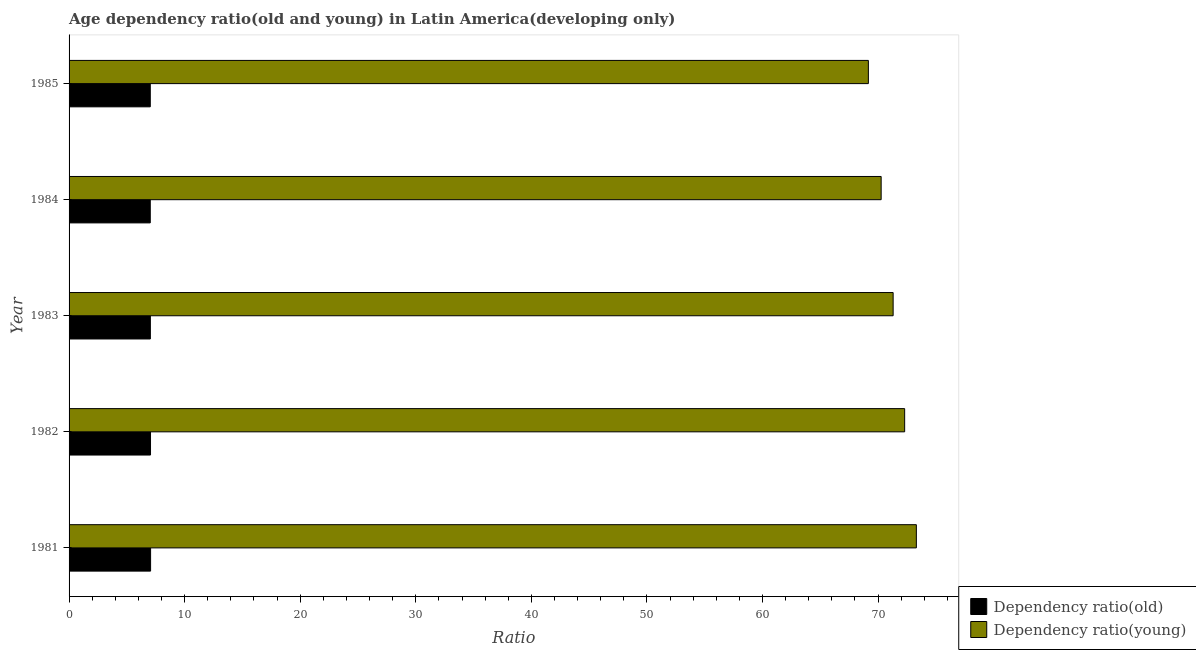How many groups of bars are there?
Offer a very short reply. 5. Are the number of bars on each tick of the Y-axis equal?
Keep it short and to the point. Yes. How many bars are there on the 4th tick from the bottom?
Ensure brevity in your answer.  2. What is the label of the 3rd group of bars from the top?
Offer a very short reply. 1983. What is the age dependency ratio(young) in 1985?
Keep it short and to the point. 69.16. Across all years, what is the maximum age dependency ratio(old)?
Your answer should be compact. 7.05. Across all years, what is the minimum age dependency ratio(young)?
Provide a succinct answer. 69.16. In which year was the age dependency ratio(young) maximum?
Your response must be concise. 1981. What is the total age dependency ratio(old) in the graph?
Ensure brevity in your answer.  35.19. What is the difference between the age dependency ratio(young) in 1981 and that in 1983?
Provide a succinct answer. 2.01. What is the difference between the age dependency ratio(young) in 1983 and the age dependency ratio(old) in 1982?
Your response must be concise. 64.26. What is the average age dependency ratio(young) per year?
Provide a short and direct response. 71.27. In the year 1981, what is the difference between the age dependency ratio(old) and age dependency ratio(young)?
Make the answer very short. -66.26. What is the ratio of the age dependency ratio(old) in 1982 to that in 1983?
Make the answer very short. 1. What is the difference between the highest and the second highest age dependency ratio(old)?
Offer a terse response. 0.01. What is the difference between the highest and the lowest age dependency ratio(old)?
Offer a very short reply. 0.03. What does the 2nd bar from the top in 1981 represents?
Provide a short and direct response. Dependency ratio(old). What does the 1st bar from the bottom in 1985 represents?
Make the answer very short. Dependency ratio(old). Does the graph contain any zero values?
Your answer should be very brief. No. How many legend labels are there?
Give a very brief answer. 2. What is the title of the graph?
Make the answer very short. Age dependency ratio(old and young) in Latin America(developing only). What is the label or title of the X-axis?
Give a very brief answer. Ratio. What is the Ratio of Dependency ratio(old) in 1981?
Offer a terse response. 7.05. What is the Ratio of Dependency ratio(young) in 1981?
Ensure brevity in your answer.  73.31. What is the Ratio of Dependency ratio(old) in 1982?
Give a very brief answer. 7.05. What is the Ratio of Dependency ratio(young) in 1982?
Your response must be concise. 72.3. What is the Ratio of Dependency ratio(old) in 1983?
Your response must be concise. 7.03. What is the Ratio in Dependency ratio(young) in 1983?
Your answer should be very brief. 71.3. What is the Ratio in Dependency ratio(old) in 1984?
Your response must be concise. 7.03. What is the Ratio in Dependency ratio(young) in 1984?
Your answer should be compact. 70.27. What is the Ratio in Dependency ratio(old) in 1985?
Provide a succinct answer. 7.03. What is the Ratio of Dependency ratio(young) in 1985?
Give a very brief answer. 69.16. Across all years, what is the maximum Ratio in Dependency ratio(old)?
Offer a very short reply. 7.05. Across all years, what is the maximum Ratio of Dependency ratio(young)?
Your answer should be compact. 73.31. Across all years, what is the minimum Ratio of Dependency ratio(old)?
Ensure brevity in your answer.  7.03. Across all years, what is the minimum Ratio in Dependency ratio(young)?
Your response must be concise. 69.16. What is the total Ratio of Dependency ratio(old) in the graph?
Offer a very short reply. 35.19. What is the total Ratio in Dependency ratio(young) in the graph?
Ensure brevity in your answer.  356.35. What is the difference between the Ratio in Dependency ratio(old) in 1981 and that in 1982?
Provide a short and direct response. 0.01. What is the difference between the Ratio in Dependency ratio(young) in 1981 and that in 1982?
Your answer should be compact. 1.01. What is the difference between the Ratio of Dependency ratio(old) in 1981 and that in 1983?
Offer a terse response. 0.02. What is the difference between the Ratio of Dependency ratio(young) in 1981 and that in 1983?
Ensure brevity in your answer.  2.01. What is the difference between the Ratio of Dependency ratio(old) in 1981 and that in 1984?
Your answer should be very brief. 0.03. What is the difference between the Ratio in Dependency ratio(young) in 1981 and that in 1984?
Provide a succinct answer. 3.05. What is the difference between the Ratio in Dependency ratio(old) in 1981 and that in 1985?
Your answer should be compact. 0.03. What is the difference between the Ratio of Dependency ratio(young) in 1981 and that in 1985?
Ensure brevity in your answer.  4.15. What is the difference between the Ratio in Dependency ratio(old) in 1982 and that in 1983?
Provide a succinct answer. 0.01. What is the difference between the Ratio of Dependency ratio(young) in 1982 and that in 1983?
Keep it short and to the point. 1. What is the difference between the Ratio in Dependency ratio(old) in 1982 and that in 1984?
Offer a very short reply. 0.02. What is the difference between the Ratio of Dependency ratio(young) in 1982 and that in 1984?
Provide a succinct answer. 2.03. What is the difference between the Ratio of Dependency ratio(old) in 1982 and that in 1985?
Your response must be concise. 0.02. What is the difference between the Ratio in Dependency ratio(young) in 1982 and that in 1985?
Offer a terse response. 3.14. What is the difference between the Ratio in Dependency ratio(old) in 1983 and that in 1984?
Offer a terse response. 0.01. What is the difference between the Ratio in Dependency ratio(young) in 1983 and that in 1984?
Give a very brief answer. 1.04. What is the difference between the Ratio of Dependency ratio(old) in 1983 and that in 1985?
Offer a very short reply. 0.01. What is the difference between the Ratio of Dependency ratio(young) in 1983 and that in 1985?
Make the answer very short. 2.14. What is the difference between the Ratio in Dependency ratio(old) in 1984 and that in 1985?
Give a very brief answer. -0. What is the difference between the Ratio in Dependency ratio(young) in 1984 and that in 1985?
Offer a very short reply. 1.11. What is the difference between the Ratio in Dependency ratio(old) in 1981 and the Ratio in Dependency ratio(young) in 1982?
Make the answer very short. -65.25. What is the difference between the Ratio of Dependency ratio(old) in 1981 and the Ratio of Dependency ratio(young) in 1983?
Keep it short and to the point. -64.25. What is the difference between the Ratio in Dependency ratio(old) in 1981 and the Ratio in Dependency ratio(young) in 1984?
Offer a terse response. -63.21. What is the difference between the Ratio in Dependency ratio(old) in 1981 and the Ratio in Dependency ratio(young) in 1985?
Provide a succinct answer. -62.11. What is the difference between the Ratio of Dependency ratio(old) in 1982 and the Ratio of Dependency ratio(young) in 1983?
Provide a short and direct response. -64.26. What is the difference between the Ratio of Dependency ratio(old) in 1982 and the Ratio of Dependency ratio(young) in 1984?
Give a very brief answer. -63.22. What is the difference between the Ratio in Dependency ratio(old) in 1982 and the Ratio in Dependency ratio(young) in 1985?
Offer a very short reply. -62.11. What is the difference between the Ratio in Dependency ratio(old) in 1983 and the Ratio in Dependency ratio(young) in 1984?
Your response must be concise. -63.23. What is the difference between the Ratio in Dependency ratio(old) in 1983 and the Ratio in Dependency ratio(young) in 1985?
Offer a terse response. -62.13. What is the difference between the Ratio of Dependency ratio(old) in 1984 and the Ratio of Dependency ratio(young) in 1985?
Offer a very short reply. -62.14. What is the average Ratio in Dependency ratio(old) per year?
Your response must be concise. 7.04. What is the average Ratio in Dependency ratio(young) per year?
Offer a terse response. 71.27. In the year 1981, what is the difference between the Ratio in Dependency ratio(old) and Ratio in Dependency ratio(young)?
Give a very brief answer. -66.26. In the year 1982, what is the difference between the Ratio of Dependency ratio(old) and Ratio of Dependency ratio(young)?
Offer a very short reply. -65.25. In the year 1983, what is the difference between the Ratio of Dependency ratio(old) and Ratio of Dependency ratio(young)?
Ensure brevity in your answer.  -64.27. In the year 1984, what is the difference between the Ratio in Dependency ratio(old) and Ratio in Dependency ratio(young)?
Provide a succinct answer. -63.24. In the year 1985, what is the difference between the Ratio of Dependency ratio(old) and Ratio of Dependency ratio(young)?
Make the answer very short. -62.13. What is the ratio of the Ratio in Dependency ratio(old) in 1981 to that in 1982?
Your answer should be compact. 1. What is the ratio of the Ratio in Dependency ratio(young) in 1981 to that in 1982?
Make the answer very short. 1.01. What is the ratio of the Ratio of Dependency ratio(young) in 1981 to that in 1983?
Ensure brevity in your answer.  1.03. What is the ratio of the Ratio in Dependency ratio(young) in 1981 to that in 1984?
Give a very brief answer. 1.04. What is the ratio of the Ratio of Dependency ratio(old) in 1981 to that in 1985?
Give a very brief answer. 1. What is the ratio of the Ratio of Dependency ratio(young) in 1981 to that in 1985?
Provide a succinct answer. 1.06. What is the ratio of the Ratio in Dependency ratio(old) in 1982 to that in 1984?
Offer a terse response. 1. What is the ratio of the Ratio of Dependency ratio(young) in 1982 to that in 1984?
Your answer should be very brief. 1.03. What is the ratio of the Ratio in Dependency ratio(old) in 1982 to that in 1985?
Keep it short and to the point. 1. What is the ratio of the Ratio in Dependency ratio(young) in 1982 to that in 1985?
Provide a succinct answer. 1.05. What is the ratio of the Ratio of Dependency ratio(old) in 1983 to that in 1984?
Give a very brief answer. 1. What is the ratio of the Ratio of Dependency ratio(young) in 1983 to that in 1984?
Your answer should be compact. 1.01. What is the ratio of the Ratio of Dependency ratio(old) in 1983 to that in 1985?
Offer a terse response. 1. What is the ratio of the Ratio of Dependency ratio(young) in 1983 to that in 1985?
Ensure brevity in your answer.  1.03. What is the difference between the highest and the second highest Ratio in Dependency ratio(old)?
Provide a succinct answer. 0.01. What is the difference between the highest and the lowest Ratio in Dependency ratio(old)?
Keep it short and to the point. 0.03. What is the difference between the highest and the lowest Ratio of Dependency ratio(young)?
Give a very brief answer. 4.15. 